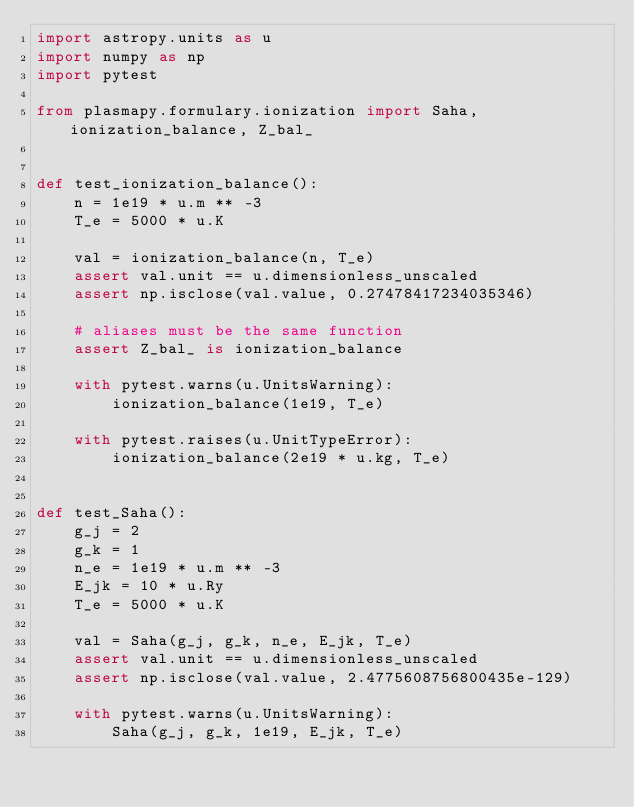Convert code to text. <code><loc_0><loc_0><loc_500><loc_500><_Python_>import astropy.units as u
import numpy as np
import pytest

from plasmapy.formulary.ionization import Saha, ionization_balance, Z_bal_


def test_ionization_balance():
    n = 1e19 * u.m ** -3
    T_e = 5000 * u.K

    val = ionization_balance(n, T_e)
    assert val.unit == u.dimensionless_unscaled
    assert np.isclose(val.value, 0.27478417234035346)

    # aliases must be the same function
    assert Z_bal_ is ionization_balance

    with pytest.warns(u.UnitsWarning):
        ionization_balance(1e19, T_e)

    with pytest.raises(u.UnitTypeError):
        ionization_balance(2e19 * u.kg, T_e)


def test_Saha():
    g_j = 2
    g_k = 1
    n_e = 1e19 * u.m ** -3
    E_jk = 10 * u.Ry
    T_e = 5000 * u.K

    val = Saha(g_j, g_k, n_e, E_jk, T_e)
    assert val.unit == u.dimensionless_unscaled
    assert np.isclose(val.value, 2.4775608756800435e-129)

    with pytest.warns(u.UnitsWarning):
        Saha(g_j, g_k, 1e19, E_jk, T_e)
</code> 